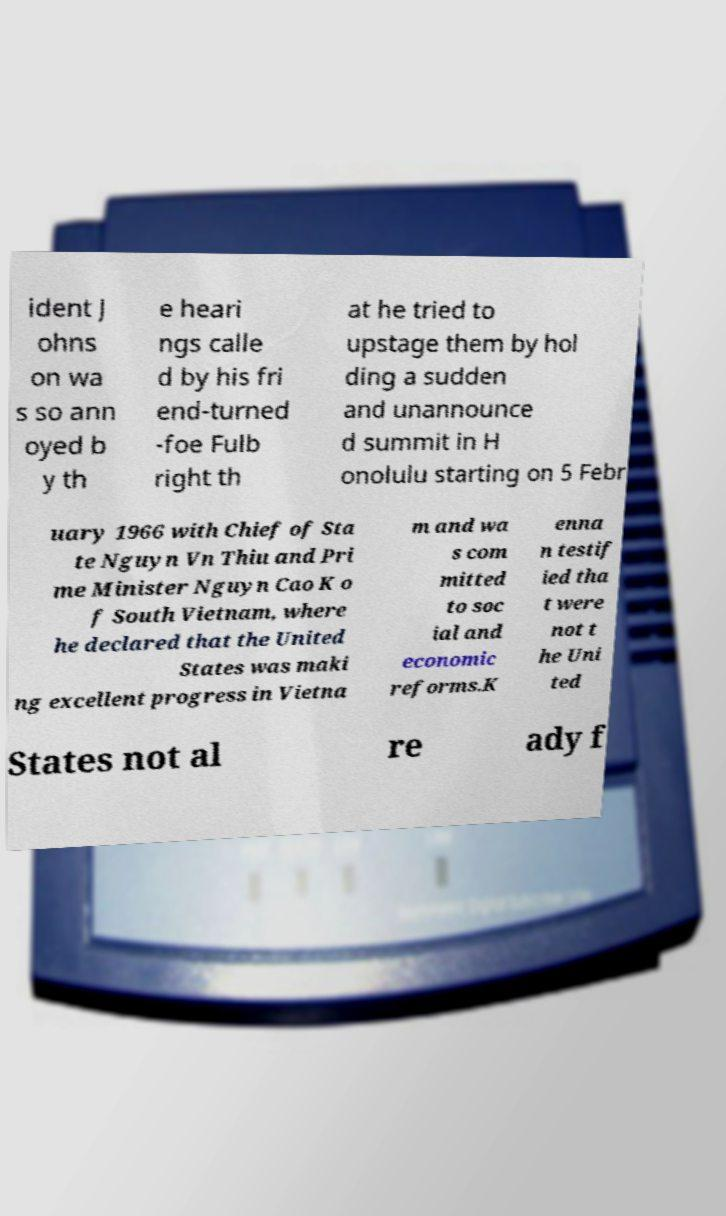What messages or text are displayed in this image? I need them in a readable, typed format. ident J ohns on wa s so ann oyed b y th e heari ngs calle d by his fri end-turned -foe Fulb right th at he tried to upstage them by hol ding a sudden and unannounce d summit in H onolulu starting on 5 Febr uary 1966 with Chief of Sta te Nguyn Vn Thiu and Pri me Minister Nguyn Cao K o f South Vietnam, where he declared that the United States was maki ng excellent progress in Vietna m and wa s com mitted to soc ial and economic reforms.K enna n testif ied tha t were not t he Uni ted States not al re ady f 